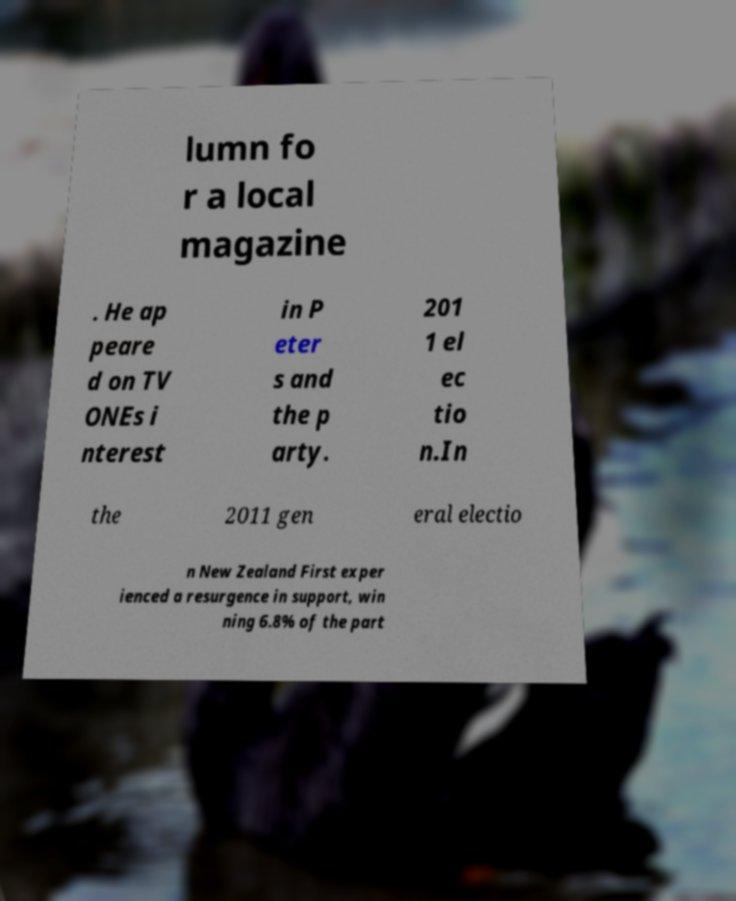Can you accurately transcribe the text from the provided image for me? lumn fo r a local magazine . He ap peare d on TV ONEs i nterest in P eter s and the p arty. 201 1 el ec tio n.In the 2011 gen eral electio n New Zealand First exper ienced a resurgence in support, win ning 6.8% of the part 